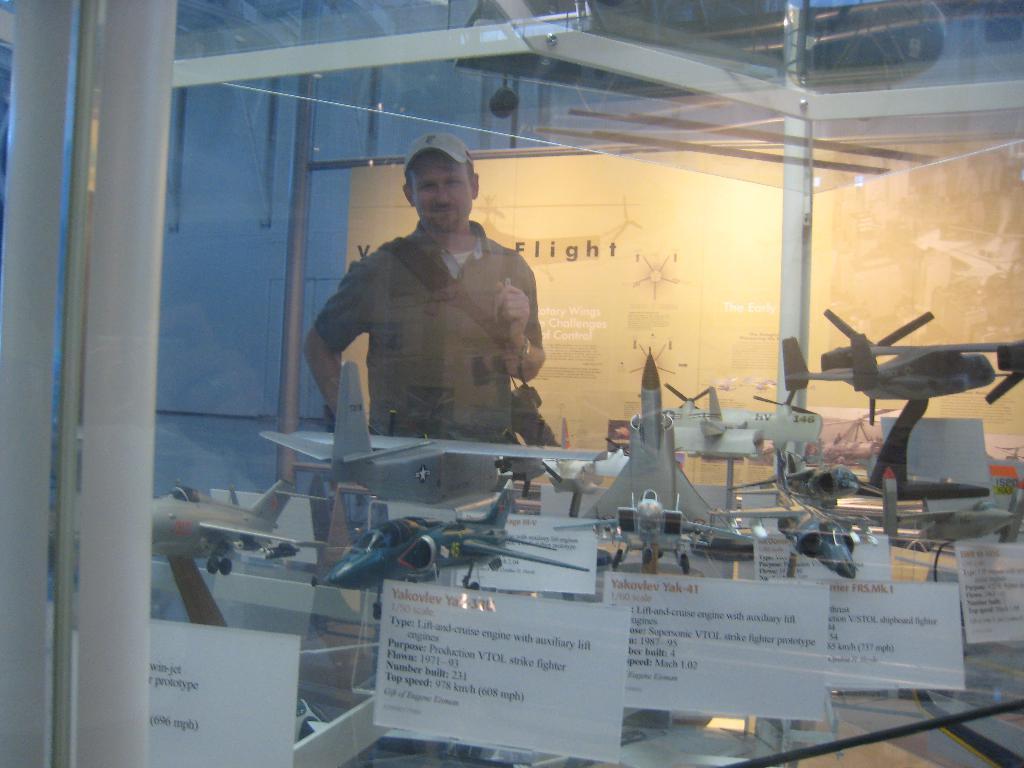Can you describe this image briefly? In this image there is a glass in the foreground. Behind the glass there are few toy airplanes kept on the glass. In between them there are name boards. In the background there is a person standing on the floor by holding the bag. Behind him there is a glass on which there is some text. On the left side there are iron poles. 